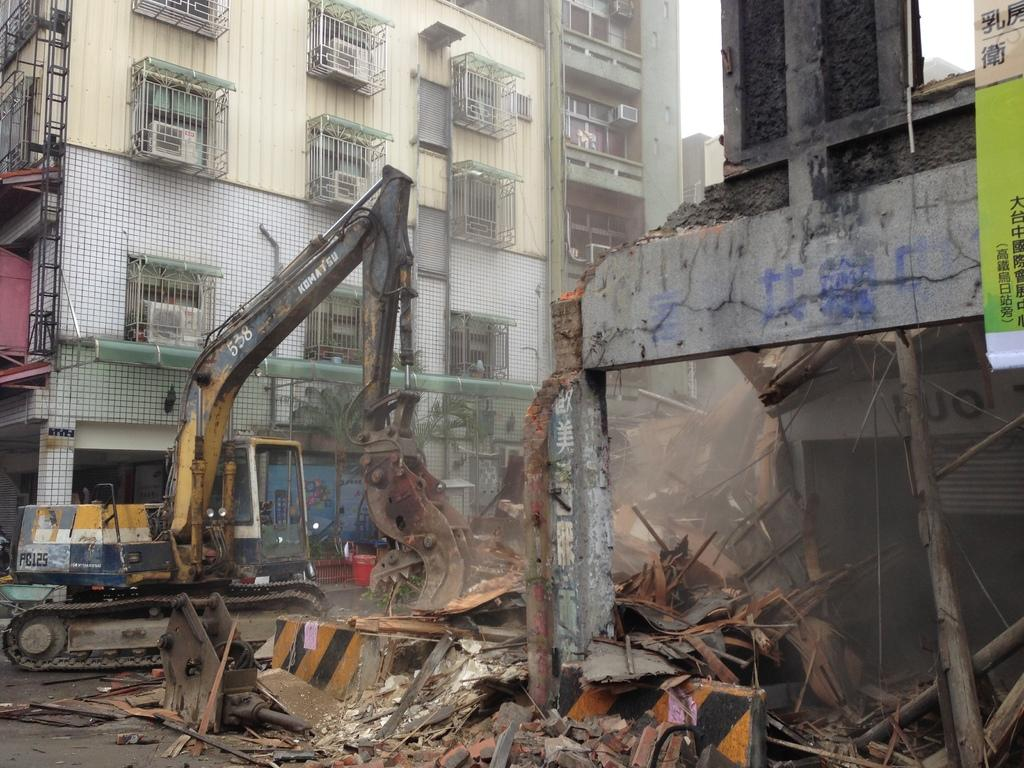What type of construction vehicle is on the road in the image? There is an excavator on the road in the image. What else can be seen in the image besides the excavator? There are banners in the image. What type of structures are visible in the image? There are buildings with windows in the image. What is visible in the background of the image? The sky is visible in the background of the image. What type of beast is roaming around the excavator in the image? There is no beast present in the image; it only features an excavator, banners, buildings, and the sky. 